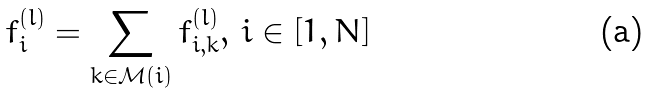Convert formula to latex. <formula><loc_0><loc_0><loc_500><loc_500>f _ { i } ^ { ( l ) } = \sum _ { k \in \mathcal { M } ( i ) } f _ { i , k } ^ { ( l ) } , \, i \in [ 1 , N ]</formula> 